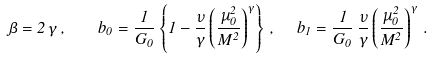Convert formula to latex. <formula><loc_0><loc_0><loc_500><loc_500>\beta = 2 \, \gamma \, , \quad b _ { 0 } = \frac { 1 } { G _ { 0 } } \left \{ 1 - \frac { \nu } { \gamma } \left ( \frac { \mu _ { 0 } ^ { 2 } } { M ^ { 2 } } \right ) ^ { \gamma } \right \} \, , \ \ b _ { 1 } = \frac { 1 } { G _ { 0 } } \, \frac { \nu } { \gamma } \left ( \frac { \mu _ { 0 } ^ { 2 } } { M ^ { 2 } } \right ) ^ { \gamma } \, .</formula> 